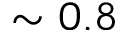Convert formula to latex. <formula><loc_0><loc_0><loc_500><loc_500>\sim 0 . 8</formula> 